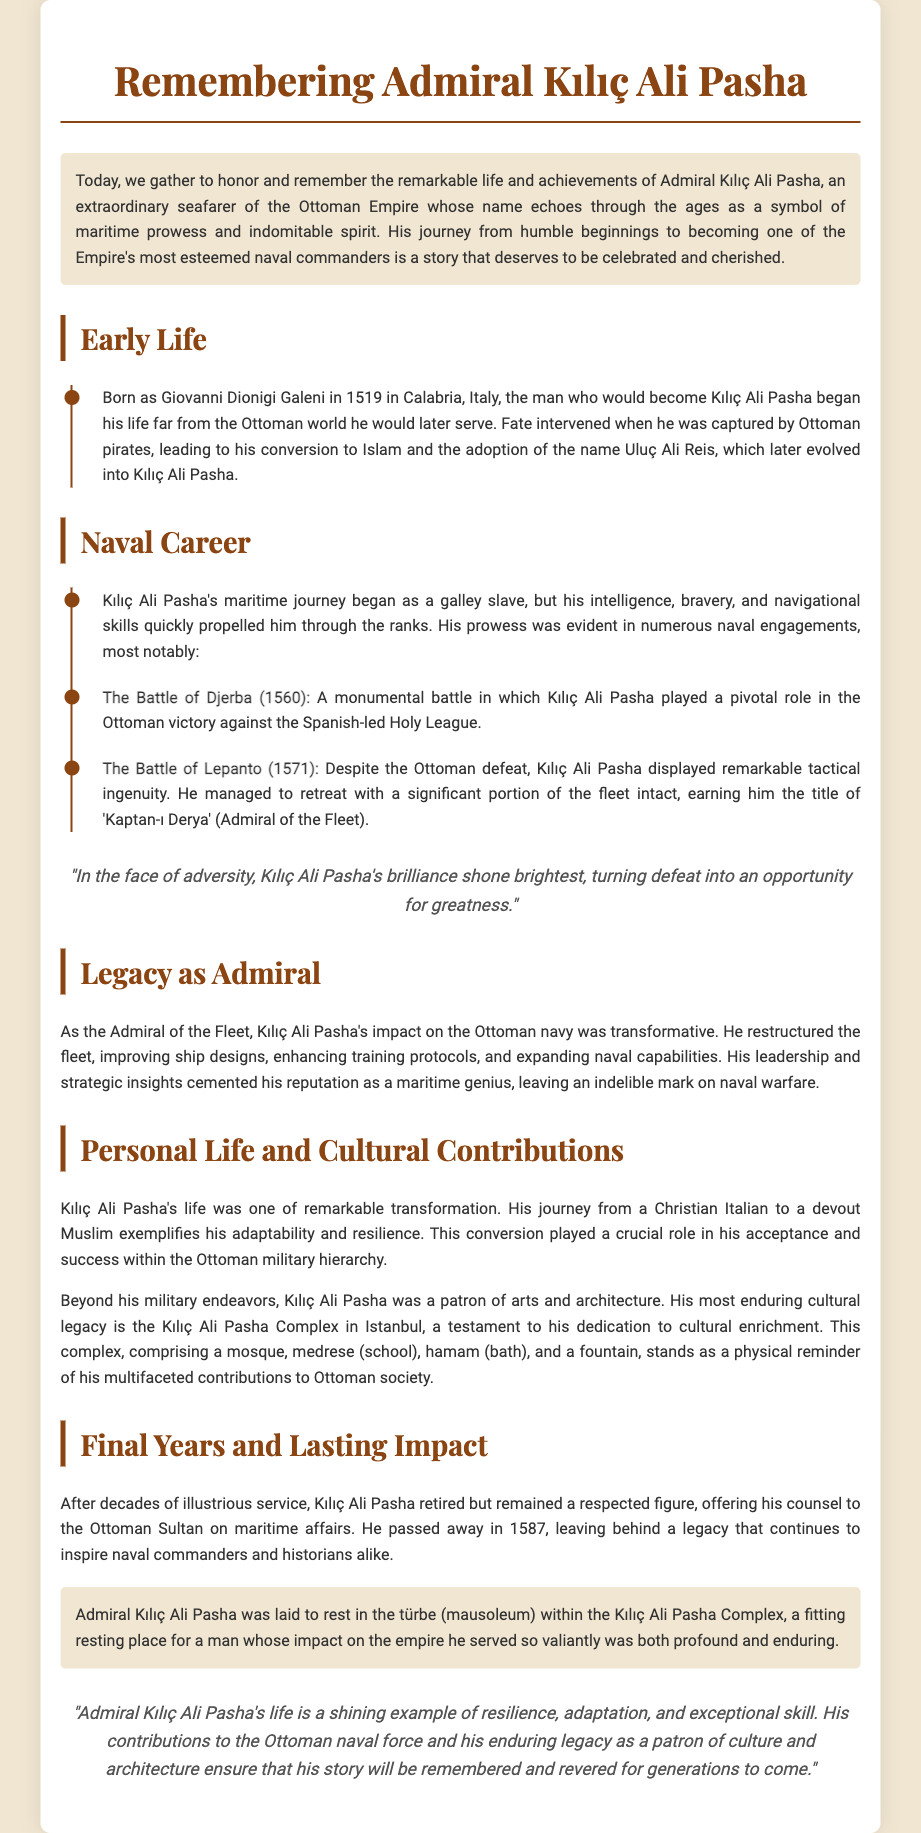What was Admiral Kılıç Ali Pasha's birth name? The document states that he was born as Giovanni Dionigi Galeni.
Answer: Giovanni Dionigi Galeni In what year was Kılıç Ali Pasha born? The document mentions that he was born in 1519.
Answer: 1519 What title did Kılıç Ali Pasha earn after the Battle of Lepanto? According to the document, he earned the title of 'Kaptan-ı Derya' (Admiral of the Fleet).
Answer: Kaptan-ı Derya What was the Kılıç Ali Pasha Complex comprised of? The document lists the components as a mosque, medrese, hamam, and a fountain.
Answer: Mosque, medrese, hamam, fountain What significant naval battle occurred in 1571? The document refers to the Battle of Lepanto as the significant battle in that year.
Answer: Battle of Lepanto How did Kılıç Ali Pasha's life exemplify transformation? The document highlights his conversion from Christianity to Islam and adaptation within the Ottoman military.
Answer: Conversion from Christianity to Islam What year did Kılıç Ali Pasha pass away? The document clearly states that he passed away in 1587.
Answer: 1587 What cultural role did Kılıç Ali Pasha serve beyond his military career? The document indicates that he was a patron of arts and architecture.
Answer: Patron of arts and architecture 